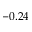Convert formula to latex. <formula><loc_0><loc_0><loc_500><loc_500>- 0 . 2 4</formula> 